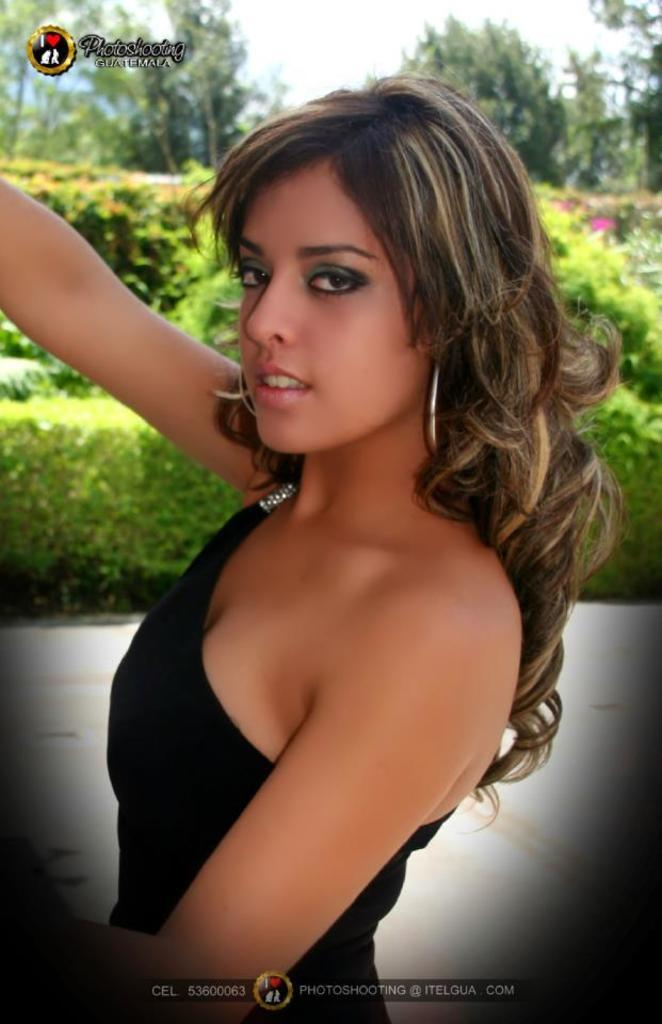Who is present in the image? There is a woman in the image. What can be seen in the background of the image? There are plants, trees, and the sky visible in the background of the image. What type of grain is visible in the image? There is no grain present in the image. What furniture can be seen in the image? There is no furniture present in the image. 